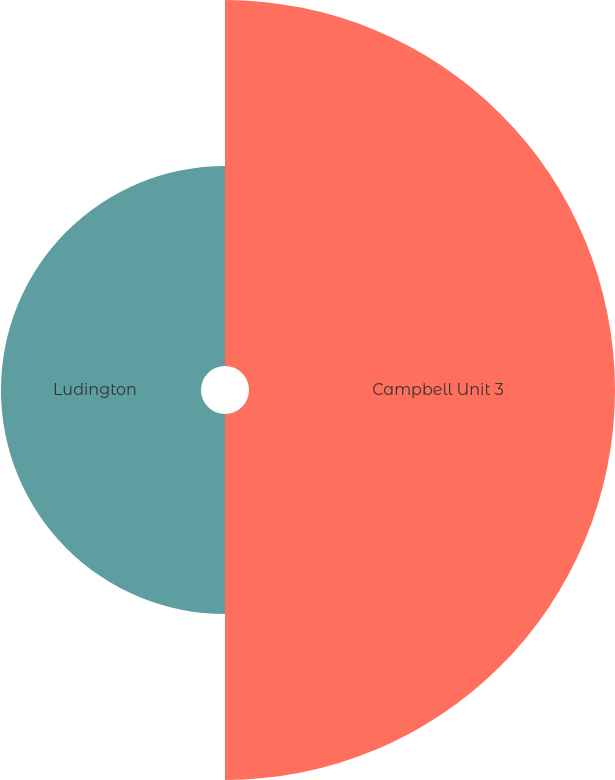Convert chart to OTSL. <chart><loc_0><loc_0><loc_500><loc_500><pie_chart><fcel>Campbell Unit 3<fcel>Ludington<nl><fcel>64.66%<fcel>35.34%<nl></chart> 